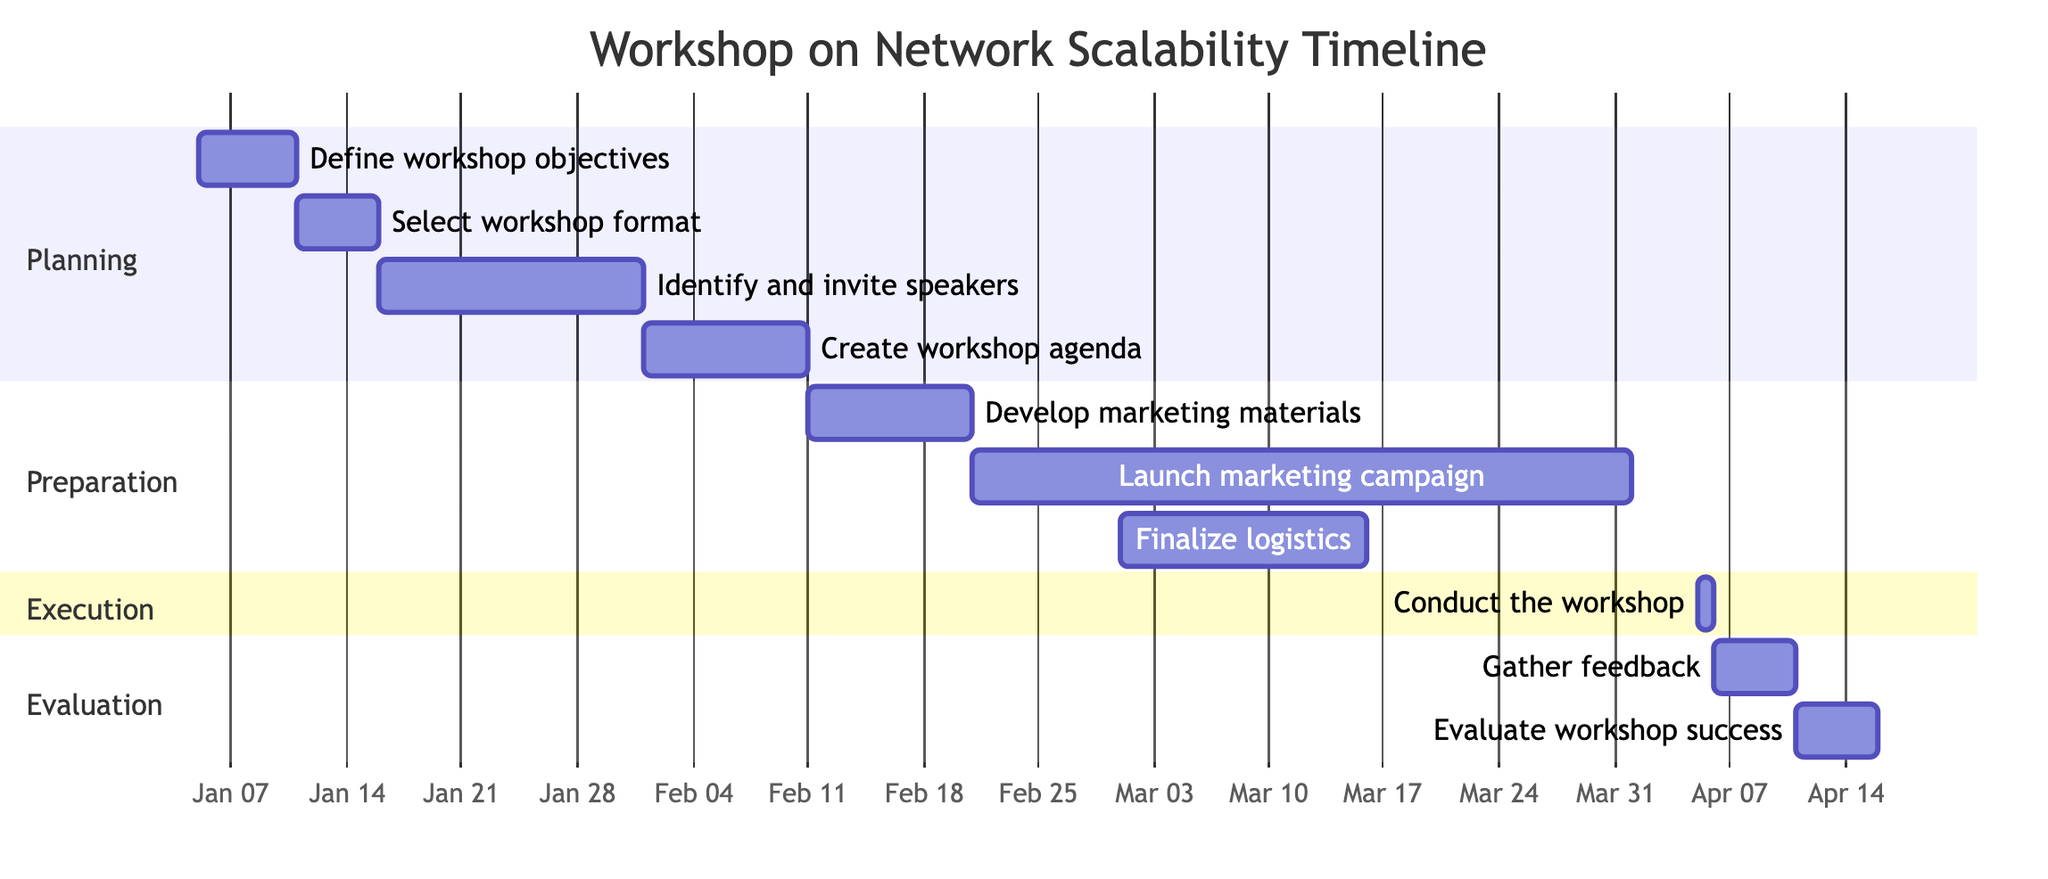What is the duration of the "Define workshop objectives" task? The start date for the "Define workshop objectives" task is January 5, 2024, and the end date is January 10, 2024. This results in a duration of 6 days.
Answer: 6 days When does the "Launch marketing campaign" begin? According to the diagram, the "Launch marketing campaign" task starts on February 21, 2024.
Answer: February 21, 2024 How many tasks are in the "Execution" section? The "Execution" section consists of a single task titled "Conduct the workshop."
Answer: 1 task What is the end date for the "Gather feedback" task? The "Gather feedback from participants" task starts on April 6, 2024, and ends on April 10, 2024. Thus, the end date for this task is April 10, 2024.
Answer: April 10, 2024 Which task overlaps with both the "Finalize logistics" and the "Conduct the workshop" tasks? The "Launch marketing campaign" task, which runs from February 21 to March 31, overlaps with "Finalize logistics" (March 1 to March 15) and "Conduct the workshop" (April 5).
Answer: Launch marketing campaign What is the total time span from the start of the first task to the end of the last task? The first task starts on January 5, 2024, and the last task ends on April 15, 2024. The total time span is from January 5 to April 15, which is 101 days.
Answer: 101 days Which task has the longest duration? Reviewing the durations of all tasks, the "Launch marketing campaign" spans from February 21 to March 31, lasting 40 days, which is the longest duration of any task in the diagram.
Answer: Launch marketing campaign What precedes the "Conduct the workshop"? The task that immediately precedes "Conduct the workshop" is "Finalize logistics," which finalizes on March 15, 2024, before the workshop day on April 5, 2024.
Answer: Finalize logistics 